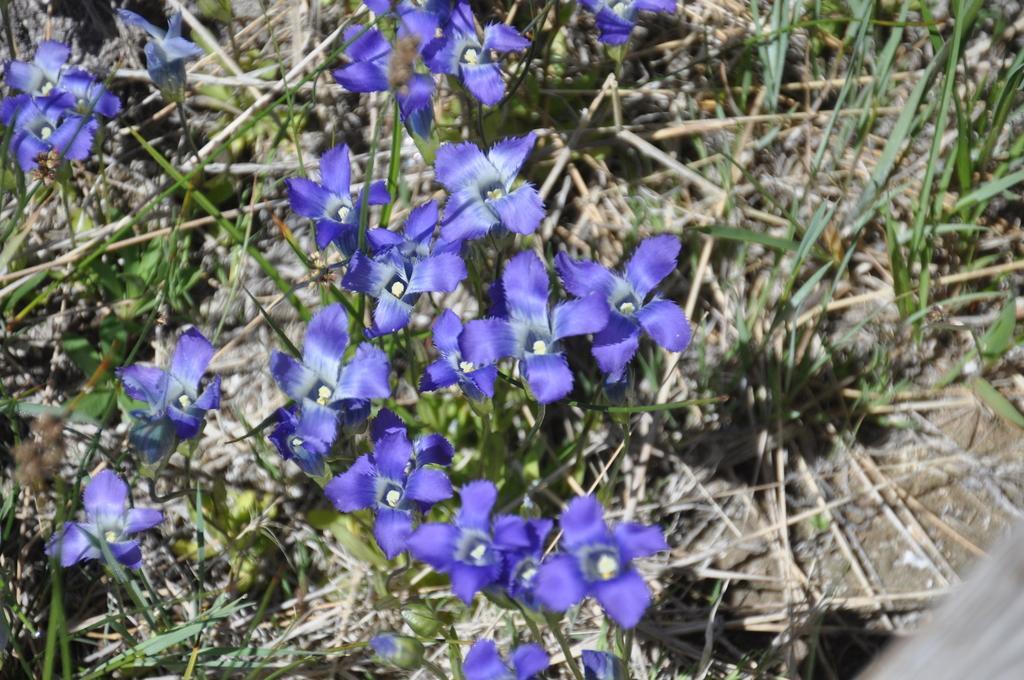How would you summarize this image in a sentence or two? In this image we can see group of flowers on plants. In the background, we can see the grass. 